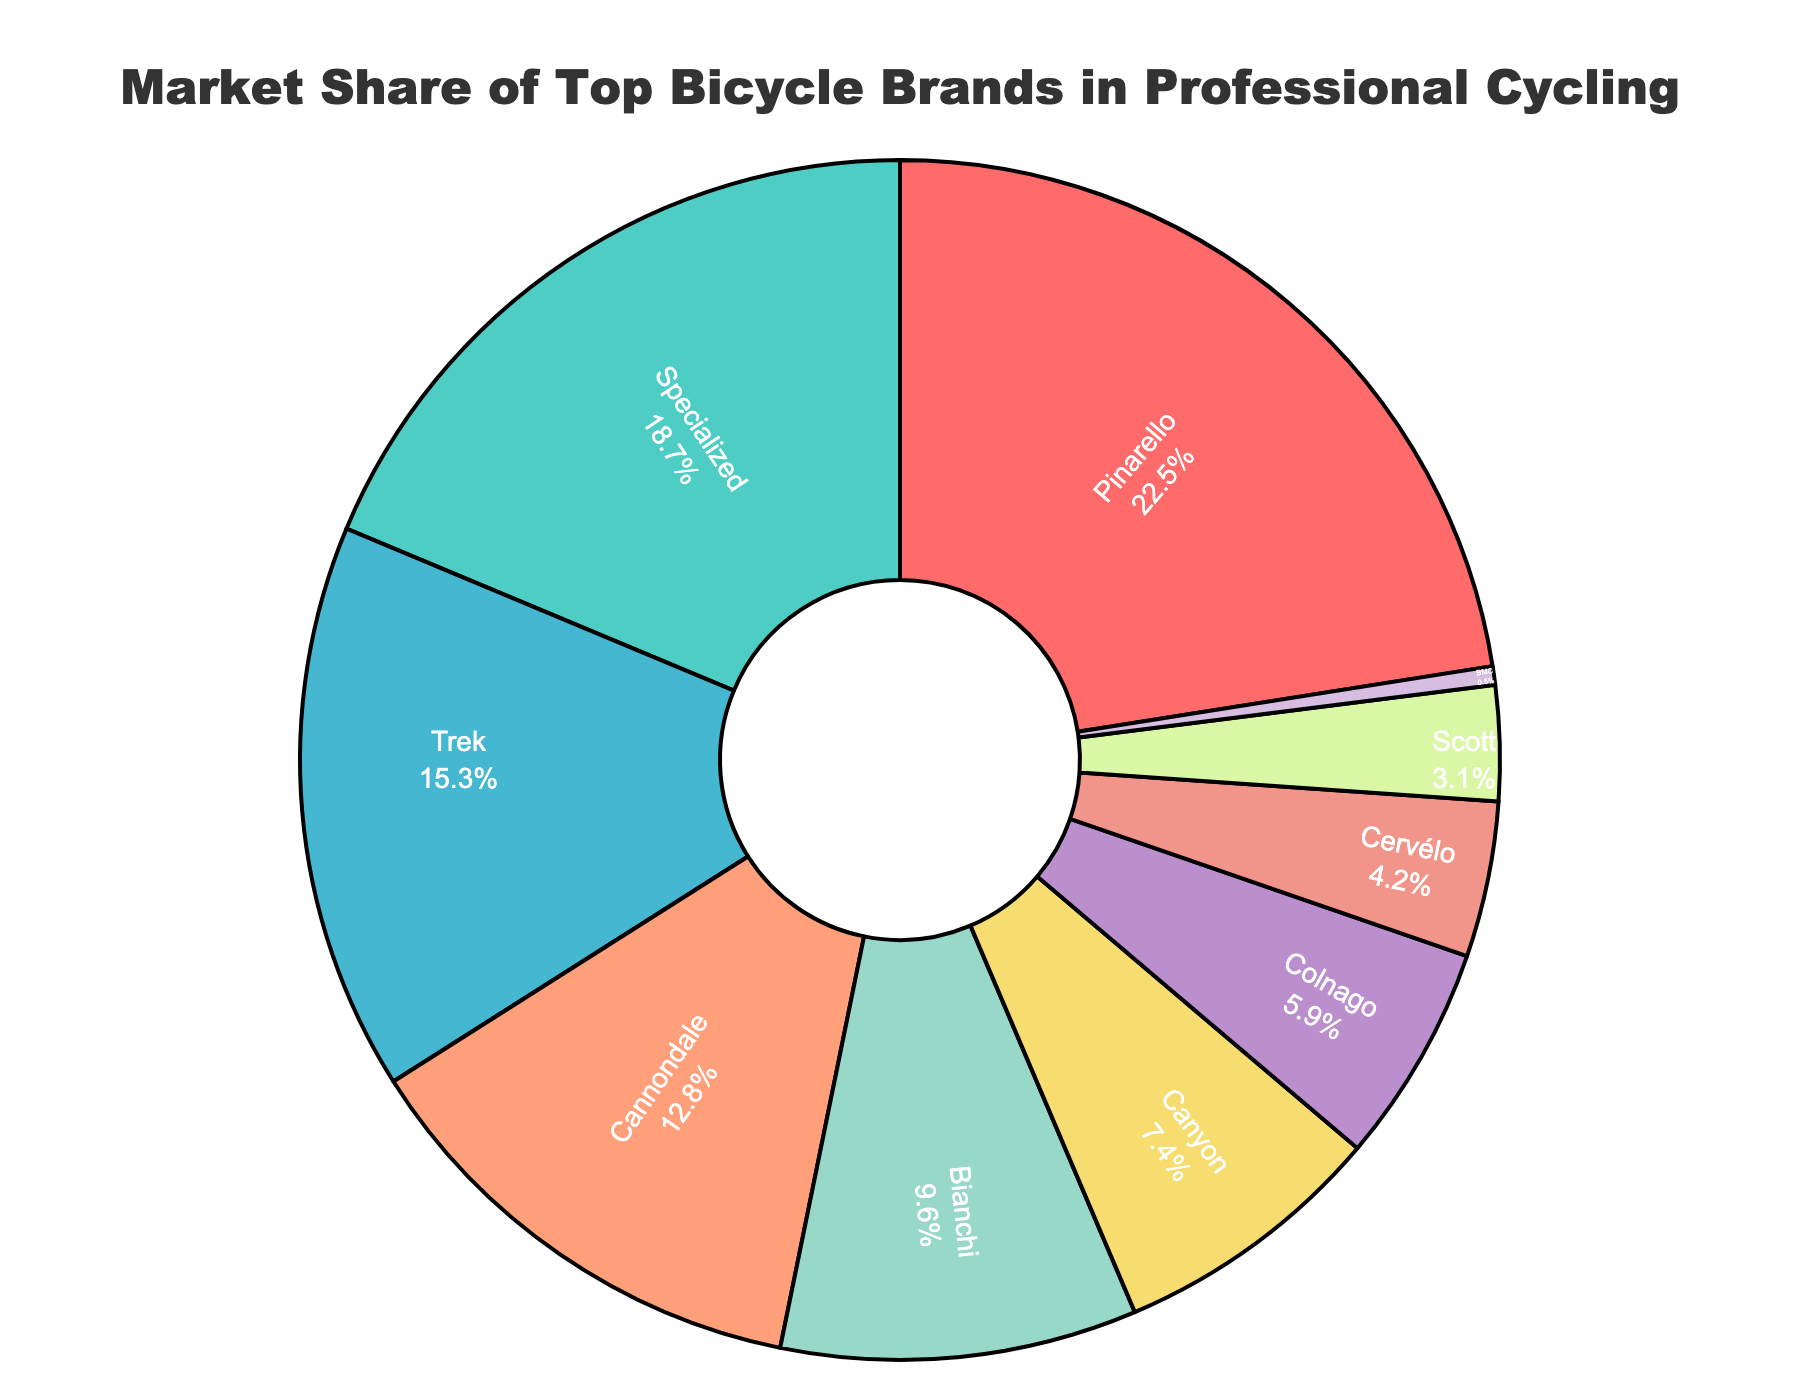What's the largest market share represented? To find the largest market share, we look for the brand with the biggest segment in the pie chart. Pinarello leads with the largest share of 22.5%.
Answer: 22.5% Which brand has the smallest market share? To determine the smallest market share, we identify the smallest segment in the pie chart. BMC has the smallest share at 0.5%.
Answer: BMC How much greater is Pinarello's market share than Bianchi's? Look at Pinarello's share (22.5%) and Bianchi's share (9.6%), then subtract Bianchi's share from Pinarello's share: 22.5% - 9.6% = 12.9%.
Answer: 12.9% Which brand market shares combined would make approximately 25%? To get a combined share of around 25%, sum the shares of brands such as Bianchi (9.6%), Canyon (7.4%), and Colnago (5.9%). Their combined share is 9.6% + 7.4% + 5.9% = 22.9%, which is approximately 25%.
Answer: Bianchi, Canyon, Colnago How does Specialized's market share compare to Trek's? Specialized’s share is 18.7% and Trek’s share is 15.3%. Thus, Specialized's market share is greater than Trek’s.
Answer: Specialized > Trek What percentage of the market is covered by the three smallest brands? The shares of the three smallest brands are Cervélo (4.2%), Scott (3.1%), and BMC (0.5%). Summing these gives 4.2% + 3.1% + 0.5% = 7.8%.
Answer: 7.8% If you remove the brand with the highest market share, what’s the new total percentage share for the remaining brands? Removing Pinarello (22.5%) from 100%, the remaining brands add up to 100% - 22.5% = 77.5%.
Answer: 77.5% Which brands have a market share less than 10% but more than 5%? The brands in this range are Bianchi (9.6%), Canyon (7.4%), and Colnago (5.9%).
Answer: Bianchi, Canyon, Colnago What color represents Pinarello and what is its market share? According to the color description, Pinarello is represented by red (#FF6B6B), and its market share is 22.5%.
Answer: Red, 22.5% 